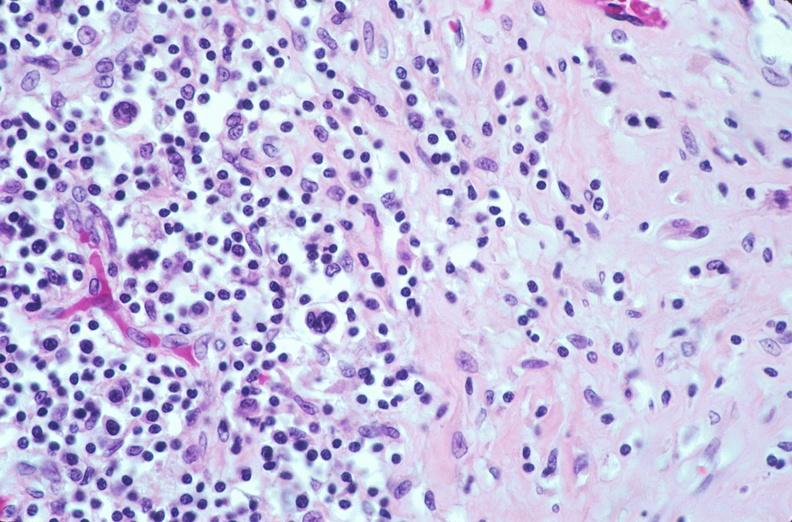does this image show lymph nodes, nodular sclerosing hodgkins disease?
Answer the question using a single word or phrase. Yes 